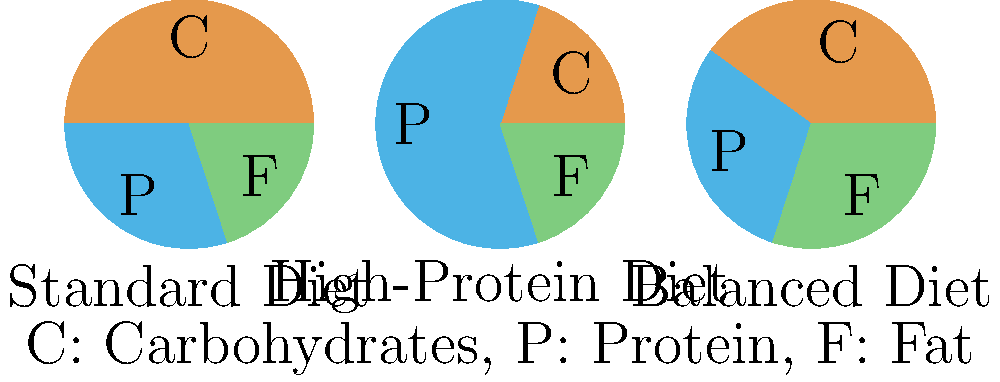Based on the pie charts showing macronutrient distribution in different diets, which diet would be most effective for someone struggling to lose weight despite trying various diet regimes? To determine the most effective diet for weight loss, we need to consider the macronutrient distribution and its impact on metabolism and satiety:

1. Standard Diet (50% Carbs, 30% Protein, 20% Fat):
   - High in carbohydrates, which can lead to blood sugar spikes and increased hunger.
   - Moderate protein, which helps with satiety but may not be enough for optimal weight loss.

2. High-Protein Diet (20% Carbs, 60% Protein, 20% Fat):
   - Low in carbohydrates, which can help reduce insulin spikes and regulate blood sugar.
   - Very high in protein, which has several benefits for weight loss:
     a) Increases satiety, reducing overall calorie intake.
     b) Has a higher thermic effect, meaning more calories are burned during digestion.
     c) Helps preserve lean muscle mass during weight loss.
   - Moderate fat content, which is essential for hormone production and nutrient absorption.

3. Balanced Diet (40% Carbs, 30% Protein, 30% Fat):
   - Moderate carbohydrate content, which may still lead to some blood sugar fluctuations.
   - Balanced protein and fat content, which can support satiety and overall health.

For someone who has tried many different diet regimes without success, the High-Protein Diet is likely to be the most effective for weight loss because:
1. It has the highest protein content, which is crucial for increasing satiety and reducing overall calorie intake.
2. The low carbohydrate content can help stabilize blood sugar levels and reduce cravings.
3. The higher protein intake can support muscle preservation during weight loss, which is important for maintaining a healthy metabolism.

While the Balanced Diet could also be beneficial, the High-Protein Diet offers a more dramatic shift in macronutrient distribution, which may be necessary for someone who has struggled with weight loss using more conventional approaches.
Answer: High-Protein Diet 